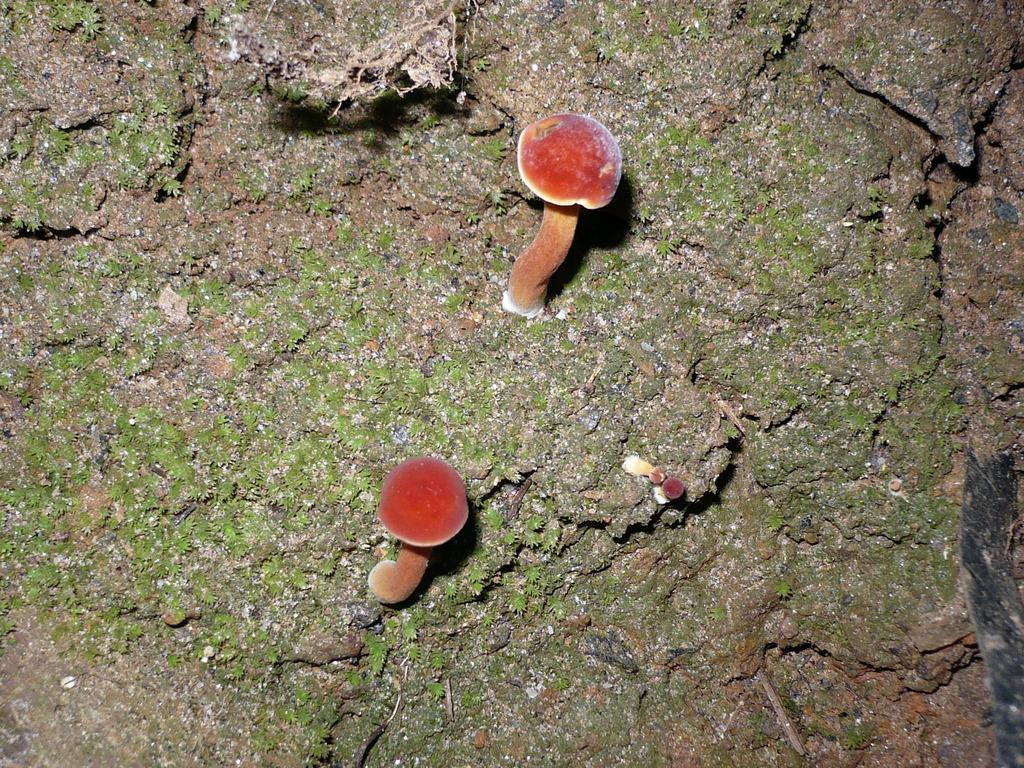What type of fungi can be seen in the image? There are mushrooms in the image. What type of shirt is the mushroom wearing in the image? Mushrooms do not wear shirts, as they are fungi and not human beings. 